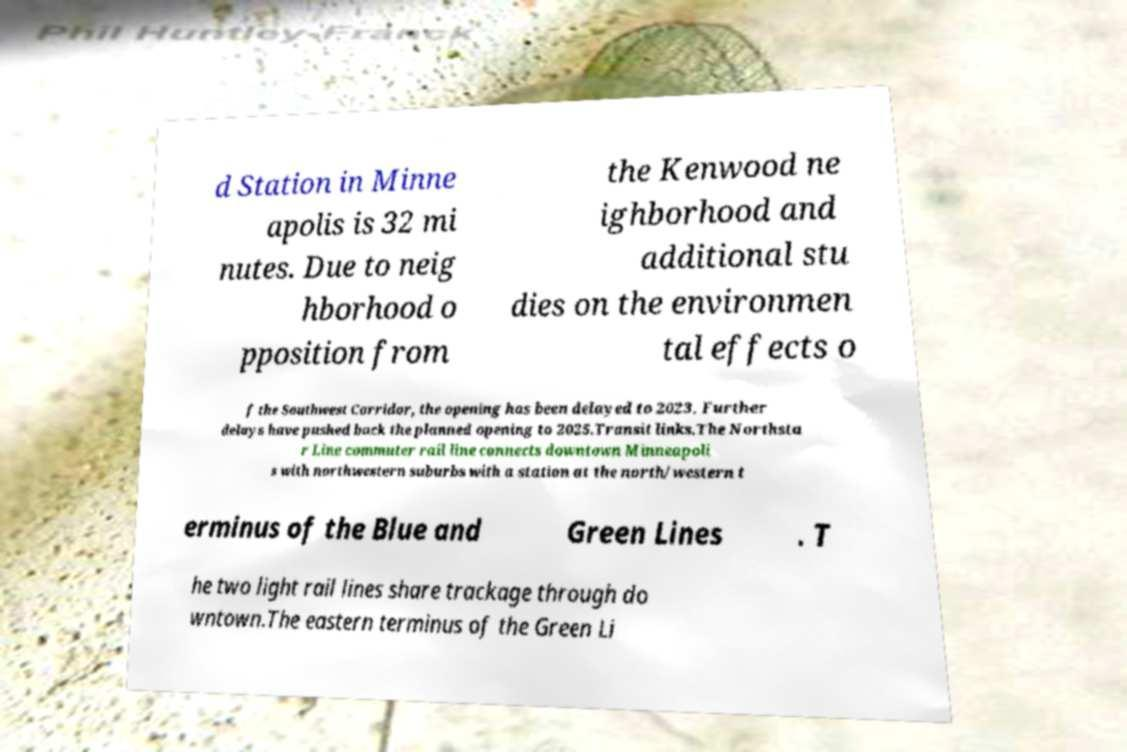Please identify and transcribe the text found in this image. d Station in Minne apolis is 32 mi nutes. Due to neig hborhood o pposition from the Kenwood ne ighborhood and additional stu dies on the environmen tal effects o f the Southwest Corridor, the opening has been delayed to 2023. Further delays have pushed back the planned opening to 2025.Transit links.The Northsta r Line commuter rail line connects downtown Minneapoli s with northwestern suburbs with a station at the north/western t erminus of the Blue and Green Lines . T he two light rail lines share trackage through do wntown.The eastern terminus of the Green Li 